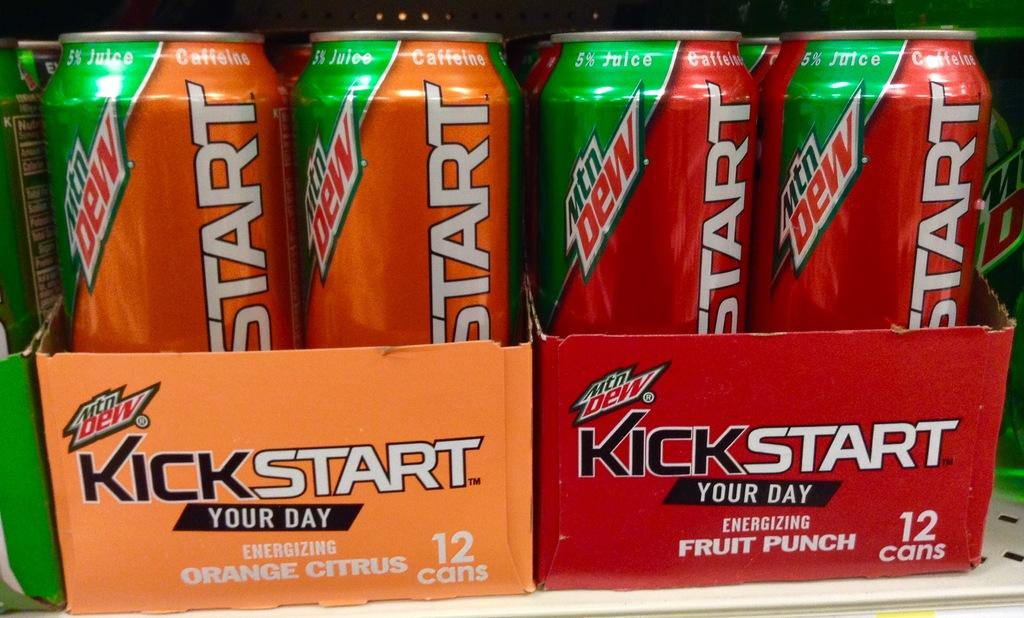<image>
Relay a brief, clear account of the picture shown. a kickstart can that is next to another one 